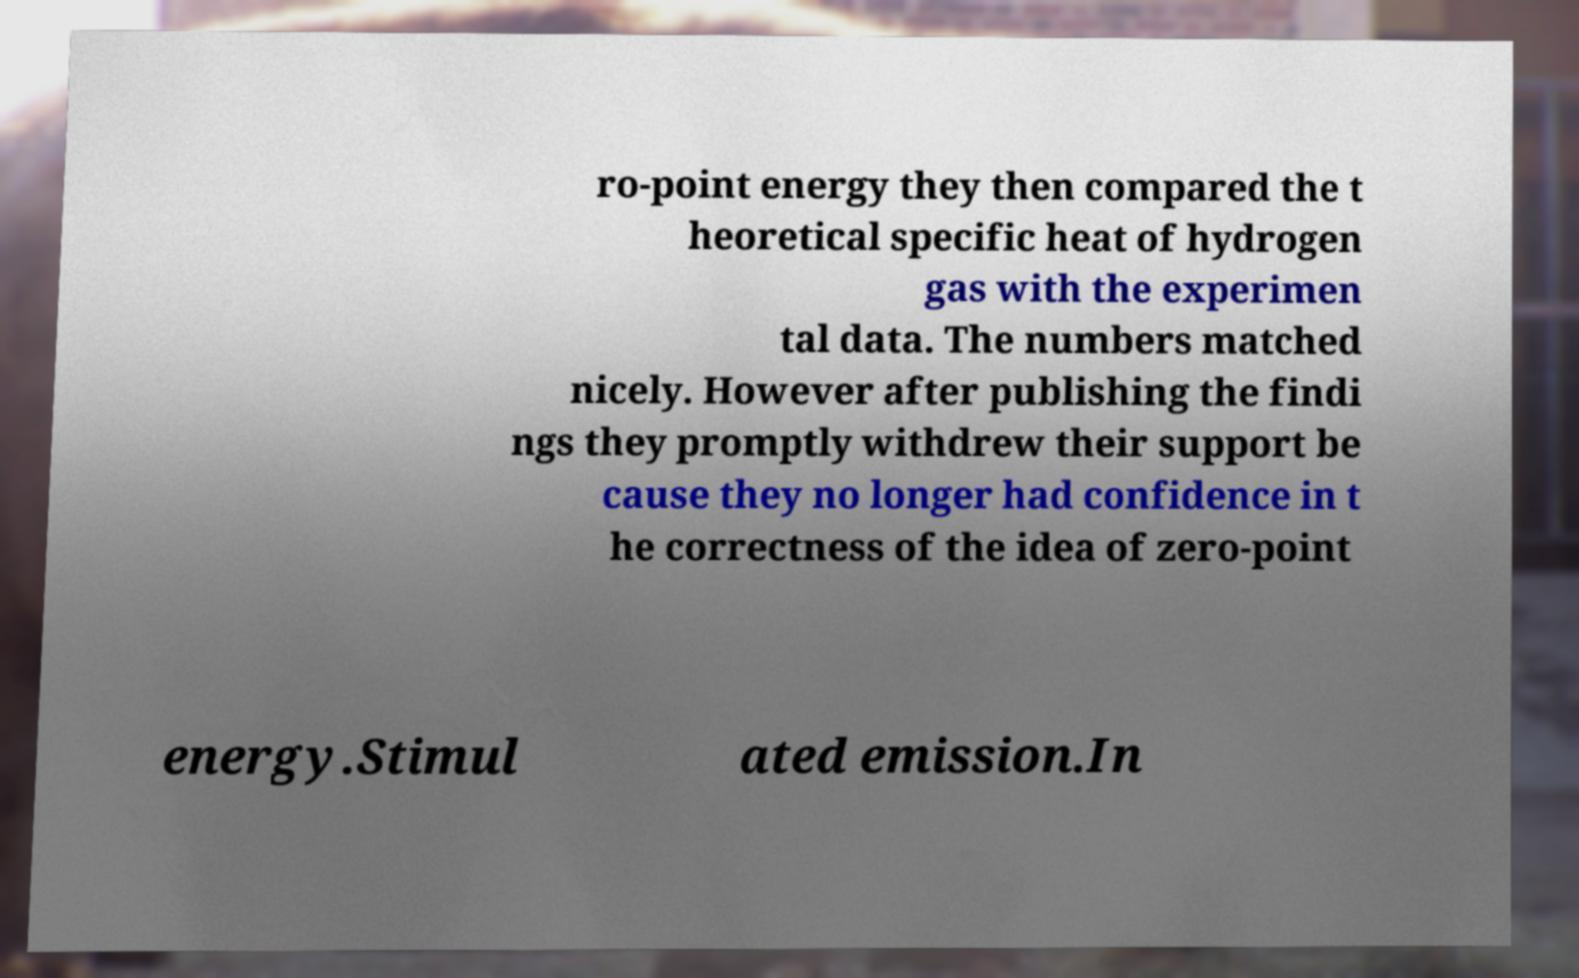Please read and relay the text visible in this image. What does it say? ro-point energy they then compared the t heoretical specific heat of hydrogen gas with the experimen tal data. The numbers matched nicely. However after publishing the findi ngs they promptly withdrew their support be cause they no longer had confidence in t he correctness of the idea of zero-point energy.Stimul ated emission.In 